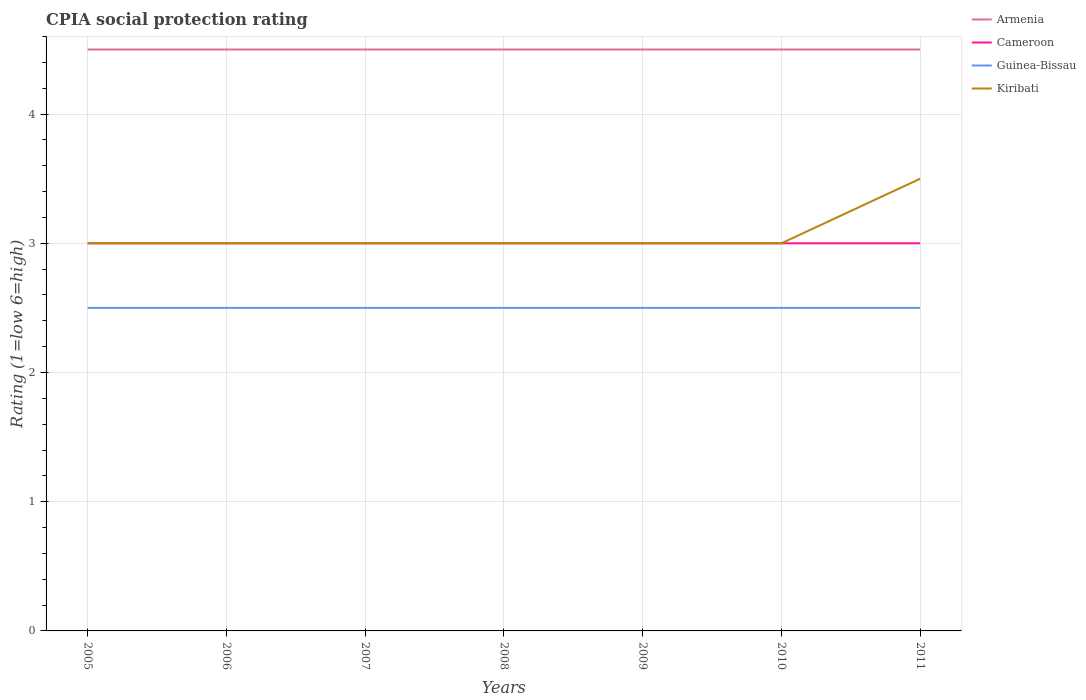Across all years, what is the maximum CPIA rating in Cameroon?
Give a very brief answer. 3. What is the total CPIA rating in Guinea-Bissau in the graph?
Your response must be concise. 0. What is the difference between the highest and the lowest CPIA rating in Armenia?
Make the answer very short. 0. Is the CPIA rating in Kiribati strictly greater than the CPIA rating in Armenia over the years?
Provide a succinct answer. Yes. How many lines are there?
Provide a short and direct response. 4. What is the difference between two consecutive major ticks on the Y-axis?
Give a very brief answer. 1. Are the values on the major ticks of Y-axis written in scientific E-notation?
Provide a short and direct response. No. Does the graph contain grids?
Make the answer very short. Yes. What is the title of the graph?
Give a very brief answer. CPIA social protection rating. What is the label or title of the X-axis?
Your answer should be compact. Years. What is the Rating (1=low 6=high) of Armenia in 2005?
Your answer should be compact. 4.5. What is the Rating (1=low 6=high) in Guinea-Bissau in 2005?
Provide a succinct answer. 2.5. What is the Rating (1=low 6=high) in Cameroon in 2007?
Your response must be concise. 3. What is the Rating (1=low 6=high) of Cameroon in 2008?
Offer a terse response. 3. What is the Rating (1=low 6=high) of Kiribati in 2008?
Your answer should be compact. 3. What is the Rating (1=low 6=high) in Guinea-Bissau in 2009?
Give a very brief answer. 2.5. What is the Rating (1=low 6=high) of Guinea-Bissau in 2010?
Offer a terse response. 2.5. What is the Rating (1=low 6=high) in Kiribati in 2010?
Provide a succinct answer. 3. What is the Rating (1=low 6=high) in Cameroon in 2011?
Make the answer very short. 3. What is the Rating (1=low 6=high) of Kiribati in 2011?
Provide a short and direct response. 3.5. Across all years, what is the maximum Rating (1=low 6=high) in Armenia?
Your answer should be very brief. 4.5. Across all years, what is the maximum Rating (1=low 6=high) of Guinea-Bissau?
Your answer should be compact. 2.5. Across all years, what is the maximum Rating (1=low 6=high) of Kiribati?
Provide a short and direct response. 3.5. Across all years, what is the minimum Rating (1=low 6=high) of Armenia?
Give a very brief answer. 4.5. Across all years, what is the minimum Rating (1=low 6=high) of Kiribati?
Ensure brevity in your answer.  3. What is the total Rating (1=low 6=high) in Armenia in the graph?
Your answer should be compact. 31.5. What is the total Rating (1=low 6=high) of Guinea-Bissau in the graph?
Provide a short and direct response. 17.5. What is the difference between the Rating (1=low 6=high) in Armenia in 2005 and that in 2006?
Your answer should be compact. 0. What is the difference between the Rating (1=low 6=high) in Cameroon in 2005 and that in 2006?
Offer a very short reply. 0. What is the difference between the Rating (1=low 6=high) of Guinea-Bissau in 2005 and that in 2006?
Offer a terse response. 0. What is the difference between the Rating (1=low 6=high) in Armenia in 2005 and that in 2007?
Give a very brief answer. 0. What is the difference between the Rating (1=low 6=high) in Cameroon in 2005 and that in 2007?
Offer a terse response. 0. What is the difference between the Rating (1=low 6=high) in Armenia in 2005 and that in 2008?
Keep it short and to the point. 0. What is the difference between the Rating (1=low 6=high) in Cameroon in 2005 and that in 2009?
Your answer should be very brief. 0. What is the difference between the Rating (1=low 6=high) of Guinea-Bissau in 2005 and that in 2009?
Provide a succinct answer. 0. What is the difference between the Rating (1=low 6=high) of Kiribati in 2005 and that in 2009?
Provide a succinct answer. 0. What is the difference between the Rating (1=low 6=high) of Cameroon in 2005 and that in 2010?
Make the answer very short. 0. What is the difference between the Rating (1=low 6=high) of Guinea-Bissau in 2005 and that in 2010?
Keep it short and to the point. 0. What is the difference between the Rating (1=low 6=high) of Cameroon in 2005 and that in 2011?
Ensure brevity in your answer.  0. What is the difference between the Rating (1=low 6=high) of Guinea-Bissau in 2005 and that in 2011?
Your answer should be very brief. 0. What is the difference between the Rating (1=low 6=high) in Kiribati in 2005 and that in 2011?
Your response must be concise. -0.5. What is the difference between the Rating (1=low 6=high) of Armenia in 2006 and that in 2007?
Give a very brief answer. 0. What is the difference between the Rating (1=low 6=high) in Cameroon in 2006 and that in 2007?
Give a very brief answer. 0. What is the difference between the Rating (1=low 6=high) in Kiribati in 2006 and that in 2007?
Provide a short and direct response. 0. What is the difference between the Rating (1=low 6=high) of Armenia in 2006 and that in 2008?
Offer a very short reply. 0. What is the difference between the Rating (1=low 6=high) of Cameroon in 2006 and that in 2008?
Provide a short and direct response. 0. What is the difference between the Rating (1=low 6=high) of Guinea-Bissau in 2006 and that in 2009?
Your answer should be very brief. 0. What is the difference between the Rating (1=low 6=high) of Guinea-Bissau in 2006 and that in 2010?
Keep it short and to the point. 0. What is the difference between the Rating (1=low 6=high) of Kiribati in 2006 and that in 2010?
Provide a succinct answer. 0. What is the difference between the Rating (1=low 6=high) of Cameroon in 2006 and that in 2011?
Offer a terse response. 0. What is the difference between the Rating (1=low 6=high) in Kiribati in 2006 and that in 2011?
Keep it short and to the point. -0.5. What is the difference between the Rating (1=low 6=high) of Kiribati in 2007 and that in 2008?
Make the answer very short. 0. What is the difference between the Rating (1=low 6=high) in Cameroon in 2007 and that in 2009?
Your answer should be compact. 0. What is the difference between the Rating (1=low 6=high) of Guinea-Bissau in 2007 and that in 2010?
Offer a terse response. 0. What is the difference between the Rating (1=low 6=high) in Cameroon in 2007 and that in 2011?
Your answer should be very brief. 0. What is the difference between the Rating (1=low 6=high) in Armenia in 2008 and that in 2009?
Your answer should be very brief. 0. What is the difference between the Rating (1=low 6=high) of Armenia in 2008 and that in 2010?
Keep it short and to the point. 0. What is the difference between the Rating (1=low 6=high) of Cameroon in 2008 and that in 2010?
Your answer should be compact. 0. What is the difference between the Rating (1=low 6=high) in Guinea-Bissau in 2008 and that in 2010?
Keep it short and to the point. 0. What is the difference between the Rating (1=low 6=high) in Kiribati in 2008 and that in 2010?
Ensure brevity in your answer.  0. What is the difference between the Rating (1=low 6=high) in Armenia in 2008 and that in 2011?
Offer a very short reply. 0. What is the difference between the Rating (1=low 6=high) of Cameroon in 2008 and that in 2011?
Provide a short and direct response. 0. What is the difference between the Rating (1=low 6=high) of Guinea-Bissau in 2008 and that in 2011?
Your answer should be compact. 0. What is the difference between the Rating (1=low 6=high) of Kiribati in 2008 and that in 2011?
Your answer should be compact. -0.5. What is the difference between the Rating (1=low 6=high) of Armenia in 2009 and that in 2010?
Ensure brevity in your answer.  0. What is the difference between the Rating (1=low 6=high) of Cameroon in 2009 and that in 2010?
Provide a short and direct response. 0. What is the difference between the Rating (1=low 6=high) of Cameroon in 2009 and that in 2011?
Offer a terse response. 0. What is the difference between the Rating (1=low 6=high) of Guinea-Bissau in 2009 and that in 2011?
Ensure brevity in your answer.  0. What is the difference between the Rating (1=low 6=high) of Armenia in 2005 and the Rating (1=low 6=high) of Cameroon in 2006?
Ensure brevity in your answer.  1.5. What is the difference between the Rating (1=low 6=high) of Armenia in 2005 and the Rating (1=low 6=high) of Guinea-Bissau in 2006?
Offer a terse response. 2. What is the difference between the Rating (1=low 6=high) in Cameroon in 2005 and the Rating (1=low 6=high) in Guinea-Bissau in 2006?
Keep it short and to the point. 0.5. What is the difference between the Rating (1=low 6=high) in Armenia in 2005 and the Rating (1=low 6=high) in Cameroon in 2007?
Your answer should be very brief. 1.5. What is the difference between the Rating (1=low 6=high) of Armenia in 2005 and the Rating (1=low 6=high) of Guinea-Bissau in 2007?
Your answer should be compact. 2. What is the difference between the Rating (1=low 6=high) in Cameroon in 2005 and the Rating (1=low 6=high) in Guinea-Bissau in 2007?
Offer a terse response. 0.5. What is the difference between the Rating (1=low 6=high) of Guinea-Bissau in 2005 and the Rating (1=low 6=high) of Kiribati in 2007?
Offer a terse response. -0.5. What is the difference between the Rating (1=low 6=high) of Armenia in 2005 and the Rating (1=low 6=high) of Cameroon in 2008?
Keep it short and to the point. 1.5. What is the difference between the Rating (1=low 6=high) of Armenia in 2005 and the Rating (1=low 6=high) of Kiribati in 2008?
Ensure brevity in your answer.  1.5. What is the difference between the Rating (1=low 6=high) of Cameroon in 2005 and the Rating (1=low 6=high) of Guinea-Bissau in 2008?
Offer a terse response. 0.5. What is the difference between the Rating (1=low 6=high) of Guinea-Bissau in 2005 and the Rating (1=low 6=high) of Kiribati in 2008?
Ensure brevity in your answer.  -0.5. What is the difference between the Rating (1=low 6=high) in Armenia in 2005 and the Rating (1=low 6=high) in Cameroon in 2009?
Provide a succinct answer. 1.5. What is the difference between the Rating (1=low 6=high) in Armenia in 2005 and the Rating (1=low 6=high) in Kiribati in 2009?
Provide a short and direct response. 1.5. What is the difference between the Rating (1=low 6=high) of Guinea-Bissau in 2005 and the Rating (1=low 6=high) of Kiribati in 2009?
Provide a short and direct response. -0.5. What is the difference between the Rating (1=low 6=high) of Armenia in 2005 and the Rating (1=low 6=high) of Kiribati in 2010?
Provide a succinct answer. 1.5. What is the difference between the Rating (1=low 6=high) of Cameroon in 2005 and the Rating (1=low 6=high) of Kiribati in 2010?
Give a very brief answer. 0. What is the difference between the Rating (1=low 6=high) in Armenia in 2005 and the Rating (1=low 6=high) in Cameroon in 2011?
Offer a terse response. 1.5. What is the difference between the Rating (1=low 6=high) in Cameroon in 2005 and the Rating (1=low 6=high) in Kiribati in 2011?
Ensure brevity in your answer.  -0.5. What is the difference between the Rating (1=low 6=high) in Guinea-Bissau in 2005 and the Rating (1=low 6=high) in Kiribati in 2011?
Your answer should be compact. -1. What is the difference between the Rating (1=low 6=high) in Armenia in 2006 and the Rating (1=low 6=high) in Guinea-Bissau in 2007?
Keep it short and to the point. 2. What is the difference between the Rating (1=low 6=high) of Armenia in 2006 and the Rating (1=low 6=high) of Kiribati in 2007?
Offer a terse response. 1.5. What is the difference between the Rating (1=low 6=high) in Cameroon in 2006 and the Rating (1=low 6=high) in Kiribati in 2007?
Offer a very short reply. 0. What is the difference between the Rating (1=low 6=high) in Armenia in 2006 and the Rating (1=low 6=high) in Guinea-Bissau in 2008?
Make the answer very short. 2. What is the difference between the Rating (1=low 6=high) of Cameroon in 2006 and the Rating (1=low 6=high) of Guinea-Bissau in 2008?
Your response must be concise. 0.5. What is the difference between the Rating (1=low 6=high) of Cameroon in 2006 and the Rating (1=low 6=high) of Kiribati in 2008?
Give a very brief answer. 0. What is the difference between the Rating (1=low 6=high) of Guinea-Bissau in 2006 and the Rating (1=low 6=high) of Kiribati in 2008?
Provide a short and direct response. -0.5. What is the difference between the Rating (1=low 6=high) of Armenia in 2006 and the Rating (1=low 6=high) of Guinea-Bissau in 2009?
Provide a short and direct response. 2. What is the difference between the Rating (1=low 6=high) in Cameroon in 2006 and the Rating (1=low 6=high) in Guinea-Bissau in 2009?
Your answer should be very brief. 0.5. What is the difference between the Rating (1=low 6=high) in Cameroon in 2006 and the Rating (1=low 6=high) in Kiribati in 2009?
Provide a succinct answer. 0. What is the difference between the Rating (1=low 6=high) in Guinea-Bissau in 2006 and the Rating (1=low 6=high) in Kiribati in 2009?
Keep it short and to the point. -0.5. What is the difference between the Rating (1=low 6=high) of Armenia in 2006 and the Rating (1=low 6=high) of Cameroon in 2010?
Offer a very short reply. 1.5. What is the difference between the Rating (1=low 6=high) in Armenia in 2006 and the Rating (1=low 6=high) in Kiribati in 2010?
Provide a short and direct response. 1.5. What is the difference between the Rating (1=low 6=high) of Cameroon in 2006 and the Rating (1=low 6=high) of Kiribati in 2010?
Keep it short and to the point. 0. What is the difference between the Rating (1=low 6=high) in Guinea-Bissau in 2006 and the Rating (1=low 6=high) in Kiribati in 2010?
Provide a short and direct response. -0.5. What is the difference between the Rating (1=low 6=high) of Armenia in 2006 and the Rating (1=low 6=high) of Cameroon in 2011?
Provide a short and direct response. 1.5. What is the difference between the Rating (1=low 6=high) in Armenia in 2006 and the Rating (1=low 6=high) in Guinea-Bissau in 2011?
Make the answer very short. 2. What is the difference between the Rating (1=low 6=high) of Armenia in 2006 and the Rating (1=low 6=high) of Kiribati in 2011?
Give a very brief answer. 1. What is the difference between the Rating (1=low 6=high) in Cameroon in 2006 and the Rating (1=low 6=high) in Kiribati in 2011?
Ensure brevity in your answer.  -0.5. What is the difference between the Rating (1=low 6=high) of Armenia in 2007 and the Rating (1=low 6=high) of Guinea-Bissau in 2008?
Offer a terse response. 2. What is the difference between the Rating (1=low 6=high) in Armenia in 2007 and the Rating (1=low 6=high) in Kiribati in 2008?
Your answer should be very brief. 1.5. What is the difference between the Rating (1=low 6=high) in Cameroon in 2007 and the Rating (1=low 6=high) in Guinea-Bissau in 2008?
Make the answer very short. 0.5. What is the difference between the Rating (1=low 6=high) in Guinea-Bissau in 2007 and the Rating (1=low 6=high) in Kiribati in 2008?
Keep it short and to the point. -0.5. What is the difference between the Rating (1=low 6=high) of Armenia in 2007 and the Rating (1=low 6=high) of Cameroon in 2009?
Offer a terse response. 1.5. What is the difference between the Rating (1=low 6=high) of Armenia in 2007 and the Rating (1=low 6=high) of Guinea-Bissau in 2009?
Keep it short and to the point. 2. What is the difference between the Rating (1=low 6=high) in Armenia in 2007 and the Rating (1=low 6=high) in Kiribati in 2009?
Offer a very short reply. 1.5. What is the difference between the Rating (1=low 6=high) of Armenia in 2007 and the Rating (1=low 6=high) of Guinea-Bissau in 2010?
Your answer should be compact. 2. What is the difference between the Rating (1=low 6=high) in Armenia in 2007 and the Rating (1=low 6=high) in Kiribati in 2010?
Make the answer very short. 1.5. What is the difference between the Rating (1=low 6=high) in Cameroon in 2007 and the Rating (1=low 6=high) in Guinea-Bissau in 2010?
Ensure brevity in your answer.  0.5. What is the difference between the Rating (1=low 6=high) in Cameroon in 2007 and the Rating (1=low 6=high) in Kiribati in 2010?
Make the answer very short. 0. What is the difference between the Rating (1=low 6=high) in Guinea-Bissau in 2007 and the Rating (1=low 6=high) in Kiribati in 2010?
Your answer should be very brief. -0.5. What is the difference between the Rating (1=low 6=high) in Armenia in 2007 and the Rating (1=low 6=high) in Cameroon in 2011?
Your answer should be very brief. 1.5. What is the difference between the Rating (1=low 6=high) in Armenia in 2007 and the Rating (1=low 6=high) in Guinea-Bissau in 2011?
Keep it short and to the point. 2. What is the difference between the Rating (1=low 6=high) in Armenia in 2007 and the Rating (1=low 6=high) in Kiribati in 2011?
Your answer should be compact. 1. What is the difference between the Rating (1=low 6=high) in Cameroon in 2007 and the Rating (1=low 6=high) in Guinea-Bissau in 2011?
Your answer should be compact. 0.5. What is the difference between the Rating (1=low 6=high) in Guinea-Bissau in 2007 and the Rating (1=low 6=high) in Kiribati in 2011?
Offer a very short reply. -1. What is the difference between the Rating (1=low 6=high) in Armenia in 2008 and the Rating (1=low 6=high) in Guinea-Bissau in 2009?
Make the answer very short. 2. What is the difference between the Rating (1=low 6=high) in Cameroon in 2008 and the Rating (1=low 6=high) in Guinea-Bissau in 2009?
Your answer should be very brief. 0.5. What is the difference between the Rating (1=low 6=high) in Cameroon in 2008 and the Rating (1=low 6=high) in Kiribati in 2009?
Offer a terse response. 0. What is the difference between the Rating (1=low 6=high) of Guinea-Bissau in 2008 and the Rating (1=low 6=high) of Kiribati in 2009?
Give a very brief answer. -0.5. What is the difference between the Rating (1=low 6=high) of Armenia in 2008 and the Rating (1=low 6=high) of Guinea-Bissau in 2010?
Make the answer very short. 2. What is the difference between the Rating (1=low 6=high) of Cameroon in 2008 and the Rating (1=low 6=high) of Kiribati in 2010?
Make the answer very short. 0. What is the difference between the Rating (1=low 6=high) in Armenia in 2008 and the Rating (1=low 6=high) in Cameroon in 2011?
Offer a very short reply. 1.5. What is the difference between the Rating (1=low 6=high) of Armenia in 2008 and the Rating (1=low 6=high) of Kiribati in 2011?
Your response must be concise. 1. What is the difference between the Rating (1=low 6=high) of Cameroon in 2008 and the Rating (1=low 6=high) of Guinea-Bissau in 2011?
Your response must be concise. 0.5. What is the difference between the Rating (1=low 6=high) in Cameroon in 2008 and the Rating (1=low 6=high) in Kiribati in 2011?
Ensure brevity in your answer.  -0.5. What is the difference between the Rating (1=low 6=high) in Armenia in 2009 and the Rating (1=low 6=high) in Cameroon in 2010?
Provide a succinct answer. 1.5. What is the difference between the Rating (1=low 6=high) in Cameroon in 2009 and the Rating (1=low 6=high) in Guinea-Bissau in 2010?
Provide a short and direct response. 0.5. What is the difference between the Rating (1=low 6=high) of Armenia in 2009 and the Rating (1=low 6=high) of Cameroon in 2011?
Make the answer very short. 1.5. What is the difference between the Rating (1=low 6=high) in Armenia in 2009 and the Rating (1=low 6=high) in Guinea-Bissau in 2011?
Your answer should be compact. 2. What is the difference between the Rating (1=low 6=high) in Armenia in 2009 and the Rating (1=low 6=high) in Kiribati in 2011?
Your response must be concise. 1. What is the difference between the Rating (1=low 6=high) of Cameroon in 2009 and the Rating (1=low 6=high) of Kiribati in 2011?
Your answer should be very brief. -0.5. What is the difference between the Rating (1=low 6=high) of Armenia in 2010 and the Rating (1=low 6=high) of Cameroon in 2011?
Your answer should be very brief. 1.5. What is the difference between the Rating (1=low 6=high) in Armenia in 2010 and the Rating (1=low 6=high) in Guinea-Bissau in 2011?
Your answer should be very brief. 2. What is the difference between the Rating (1=low 6=high) of Cameroon in 2010 and the Rating (1=low 6=high) of Guinea-Bissau in 2011?
Give a very brief answer. 0.5. What is the difference between the Rating (1=low 6=high) in Cameroon in 2010 and the Rating (1=low 6=high) in Kiribati in 2011?
Your response must be concise. -0.5. What is the difference between the Rating (1=low 6=high) in Guinea-Bissau in 2010 and the Rating (1=low 6=high) in Kiribati in 2011?
Offer a terse response. -1. What is the average Rating (1=low 6=high) of Armenia per year?
Provide a short and direct response. 4.5. What is the average Rating (1=low 6=high) of Cameroon per year?
Ensure brevity in your answer.  3. What is the average Rating (1=low 6=high) of Kiribati per year?
Offer a very short reply. 3.07. In the year 2005, what is the difference between the Rating (1=low 6=high) in Armenia and Rating (1=low 6=high) in Guinea-Bissau?
Keep it short and to the point. 2. In the year 2005, what is the difference between the Rating (1=low 6=high) in Cameroon and Rating (1=low 6=high) in Kiribati?
Give a very brief answer. 0. In the year 2005, what is the difference between the Rating (1=low 6=high) of Guinea-Bissau and Rating (1=low 6=high) of Kiribati?
Ensure brevity in your answer.  -0.5. In the year 2006, what is the difference between the Rating (1=low 6=high) of Cameroon and Rating (1=low 6=high) of Guinea-Bissau?
Provide a succinct answer. 0.5. In the year 2006, what is the difference between the Rating (1=low 6=high) of Cameroon and Rating (1=low 6=high) of Kiribati?
Give a very brief answer. 0. In the year 2006, what is the difference between the Rating (1=low 6=high) of Guinea-Bissau and Rating (1=low 6=high) of Kiribati?
Your answer should be compact. -0.5. In the year 2007, what is the difference between the Rating (1=low 6=high) of Armenia and Rating (1=low 6=high) of Cameroon?
Make the answer very short. 1.5. In the year 2008, what is the difference between the Rating (1=low 6=high) of Armenia and Rating (1=low 6=high) of Cameroon?
Provide a short and direct response. 1.5. In the year 2008, what is the difference between the Rating (1=low 6=high) in Armenia and Rating (1=low 6=high) in Guinea-Bissau?
Your answer should be compact. 2. In the year 2008, what is the difference between the Rating (1=low 6=high) of Armenia and Rating (1=low 6=high) of Kiribati?
Your response must be concise. 1.5. In the year 2008, what is the difference between the Rating (1=low 6=high) in Cameroon and Rating (1=low 6=high) in Kiribati?
Provide a short and direct response. 0. In the year 2008, what is the difference between the Rating (1=low 6=high) of Guinea-Bissau and Rating (1=low 6=high) of Kiribati?
Your response must be concise. -0.5. In the year 2009, what is the difference between the Rating (1=low 6=high) of Armenia and Rating (1=low 6=high) of Cameroon?
Offer a terse response. 1.5. In the year 2009, what is the difference between the Rating (1=low 6=high) of Armenia and Rating (1=low 6=high) of Guinea-Bissau?
Make the answer very short. 2. In the year 2009, what is the difference between the Rating (1=low 6=high) in Guinea-Bissau and Rating (1=low 6=high) in Kiribati?
Your answer should be very brief. -0.5. In the year 2010, what is the difference between the Rating (1=low 6=high) of Armenia and Rating (1=low 6=high) of Cameroon?
Give a very brief answer. 1.5. In the year 2010, what is the difference between the Rating (1=low 6=high) of Armenia and Rating (1=low 6=high) of Guinea-Bissau?
Provide a succinct answer. 2. In the year 2010, what is the difference between the Rating (1=low 6=high) of Cameroon and Rating (1=low 6=high) of Guinea-Bissau?
Ensure brevity in your answer.  0.5. In the year 2011, what is the difference between the Rating (1=low 6=high) in Armenia and Rating (1=low 6=high) in Cameroon?
Provide a short and direct response. 1.5. In the year 2011, what is the difference between the Rating (1=low 6=high) of Armenia and Rating (1=low 6=high) of Guinea-Bissau?
Ensure brevity in your answer.  2. What is the ratio of the Rating (1=low 6=high) in Cameroon in 2005 to that in 2006?
Your response must be concise. 1. What is the ratio of the Rating (1=low 6=high) of Kiribati in 2005 to that in 2006?
Make the answer very short. 1. What is the ratio of the Rating (1=low 6=high) of Armenia in 2005 to that in 2007?
Offer a terse response. 1. What is the ratio of the Rating (1=low 6=high) of Cameroon in 2005 to that in 2007?
Your answer should be compact. 1. What is the ratio of the Rating (1=low 6=high) of Guinea-Bissau in 2005 to that in 2007?
Make the answer very short. 1. What is the ratio of the Rating (1=low 6=high) in Kiribati in 2005 to that in 2007?
Offer a very short reply. 1. What is the ratio of the Rating (1=low 6=high) of Armenia in 2005 to that in 2008?
Provide a short and direct response. 1. What is the ratio of the Rating (1=low 6=high) in Cameroon in 2005 to that in 2008?
Your answer should be very brief. 1. What is the ratio of the Rating (1=low 6=high) in Guinea-Bissau in 2005 to that in 2008?
Your answer should be compact. 1. What is the ratio of the Rating (1=low 6=high) in Armenia in 2005 to that in 2009?
Your response must be concise. 1. What is the ratio of the Rating (1=low 6=high) of Cameroon in 2005 to that in 2009?
Your response must be concise. 1. What is the ratio of the Rating (1=low 6=high) in Guinea-Bissau in 2005 to that in 2010?
Give a very brief answer. 1. What is the ratio of the Rating (1=low 6=high) of Kiribati in 2005 to that in 2010?
Your answer should be very brief. 1. What is the ratio of the Rating (1=low 6=high) of Cameroon in 2005 to that in 2011?
Keep it short and to the point. 1. What is the ratio of the Rating (1=low 6=high) in Guinea-Bissau in 2005 to that in 2011?
Keep it short and to the point. 1. What is the ratio of the Rating (1=low 6=high) of Kiribati in 2005 to that in 2011?
Offer a terse response. 0.86. What is the ratio of the Rating (1=low 6=high) in Cameroon in 2006 to that in 2007?
Provide a short and direct response. 1. What is the ratio of the Rating (1=low 6=high) in Guinea-Bissau in 2006 to that in 2007?
Offer a terse response. 1. What is the ratio of the Rating (1=low 6=high) of Kiribati in 2006 to that in 2007?
Your answer should be compact. 1. What is the ratio of the Rating (1=low 6=high) of Armenia in 2006 to that in 2008?
Make the answer very short. 1. What is the ratio of the Rating (1=low 6=high) in Cameroon in 2006 to that in 2008?
Keep it short and to the point. 1. What is the ratio of the Rating (1=low 6=high) in Armenia in 2006 to that in 2009?
Provide a short and direct response. 1. What is the ratio of the Rating (1=low 6=high) of Cameroon in 2006 to that in 2009?
Your answer should be very brief. 1. What is the ratio of the Rating (1=low 6=high) of Guinea-Bissau in 2006 to that in 2009?
Your answer should be very brief. 1. What is the ratio of the Rating (1=low 6=high) of Armenia in 2006 to that in 2010?
Make the answer very short. 1. What is the ratio of the Rating (1=low 6=high) of Cameroon in 2006 to that in 2010?
Ensure brevity in your answer.  1. What is the ratio of the Rating (1=low 6=high) in Guinea-Bissau in 2006 to that in 2010?
Your response must be concise. 1. What is the ratio of the Rating (1=low 6=high) of Armenia in 2006 to that in 2011?
Offer a terse response. 1. What is the ratio of the Rating (1=low 6=high) in Guinea-Bissau in 2007 to that in 2008?
Keep it short and to the point. 1. What is the ratio of the Rating (1=low 6=high) of Cameroon in 2007 to that in 2009?
Your answer should be very brief. 1. What is the ratio of the Rating (1=low 6=high) of Cameroon in 2007 to that in 2010?
Provide a short and direct response. 1. What is the ratio of the Rating (1=low 6=high) of Guinea-Bissau in 2007 to that in 2010?
Your answer should be compact. 1. What is the ratio of the Rating (1=low 6=high) of Kiribati in 2007 to that in 2010?
Your response must be concise. 1. What is the ratio of the Rating (1=low 6=high) of Guinea-Bissau in 2007 to that in 2011?
Ensure brevity in your answer.  1. What is the ratio of the Rating (1=low 6=high) in Kiribati in 2008 to that in 2010?
Make the answer very short. 1. What is the ratio of the Rating (1=low 6=high) in Guinea-Bissau in 2008 to that in 2011?
Make the answer very short. 1. What is the ratio of the Rating (1=low 6=high) in Kiribati in 2008 to that in 2011?
Ensure brevity in your answer.  0.86. What is the ratio of the Rating (1=low 6=high) of Armenia in 2009 to that in 2010?
Your answer should be very brief. 1. What is the ratio of the Rating (1=low 6=high) of Cameroon in 2009 to that in 2010?
Provide a short and direct response. 1. What is the ratio of the Rating (1=low 6=high) of Guinea-Bissau in 2009 to that in 2010?
Your answer should be very brief. 1. What is the ratio of the Rating (1=low 6=high) in Cameroon in 2009 to that in 2011?
Offer a terse response. 1. What is the ratio of the Rating (1=low 6=high) in Guinea-Bissau in 2010 to that in 2011?
Your answer should be very brief. 1. What is the difference between the highest and the second highest Rating (1=low 6=high) of Armenia?
Provide a succinct answer. 0. What is the difference between the highest and the second highest Rating (1=low 6=high) in Cameroon?
Give a very brief answer. 0. What is the difference between the highest and the lowest Rating (1=low 6=high) of Guinea-Bissau?
Your answer should be compact. 0. What is the difference between the highest and the lowest Rating (1=low 6=high) of Kiribati?
Keep it short and to the point. 0.5. 